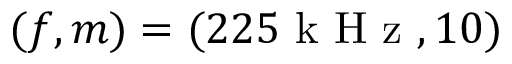<formula> <loc_0><loc_0><loc_500><loc_500>( f , m ) = ( 2 2 5 k H z , 1 0 )</formula> 